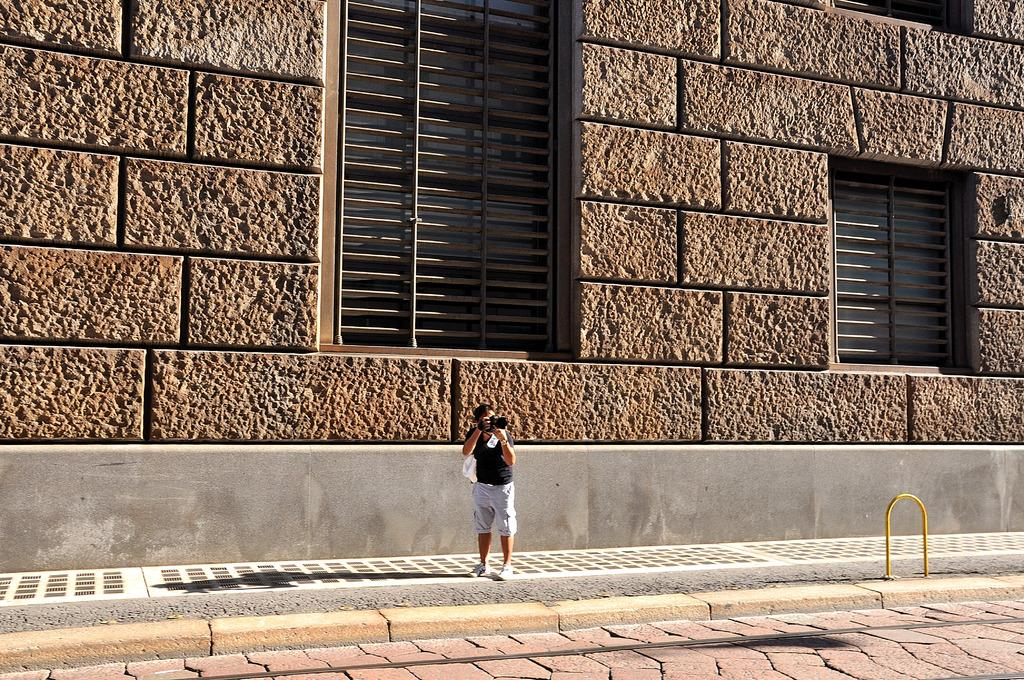Who or what is the main subject in the image? There is a person in the image. What is the person doing in the image? The person is standing. What is the person holding in the image? The person is holding a camera. What can be seen in the background of the image? There are windows and a wall in the background of the image. What type of bath can be seen in the image? There is no bath present in the image. Is the person in the image an actor? The image does not provide information about the person's profession, so we cannot determine if they are an actor. 